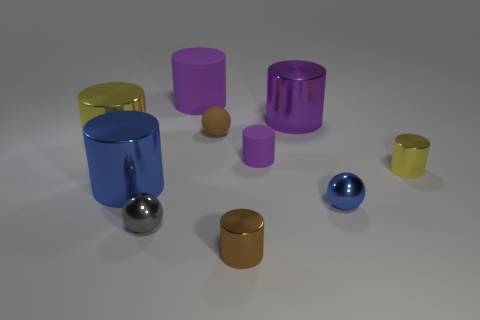Are there any red matte cubes that have the same size as the brown sphere?
Give a very brief answer. No. There is a tiny metal thing that is on the left side of the big purple rubber thing left of the brown thing that is in front of the tiny yellow metallic cylinder; what shape is it?
Make the answer very short. Sphere. Is the number of big metallic objects that are in front of the small yellow cylinder greater than the number of small gray matte spheres?
Give a very brief answer. Yes. Are there any big metallic objects of the same shape as the brown rubber thing?
Your answer should be very brief. No. Does the small blue ball have the same material as the sphere behind the big yellow cylinder?
Your answer should be very brief. No. The small rubber sphere has what color?
Offer a terse response. Brown. There is a yellow thing on the right side of the blue metal object that is on the left side of the brown matte thing; what number of objects are left of it?
Your answer should be compact. 9. Are there any yellow shiny things on the right side of the gray metallic ball?
Give a very brief answer. Yes. How many brown cylinders have the same material as the brown ball?
Offer a terse response. 0. What number of objects are big purple rubber cylinders or blue shiny objects?
Your response must be concise. 3. 